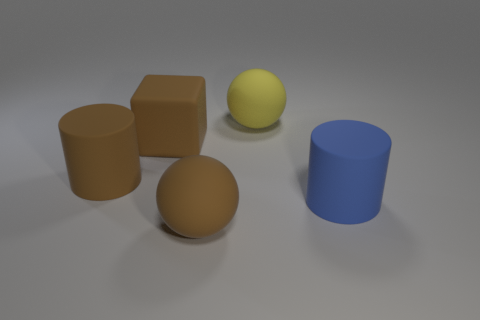What size is the rubber cylinder that is the same color as the cube?
Give a very brief answer. Large. Are there any other objects that have the same shape as the large blue matte object?
Make the answer very short. Yes. There is a brown matte object that is on the left side of the big brown rubber block; is it the same shape as the big matte object that is in front of the large blue thing?
Provide a succinct answer. No. There is a rubber object that is to the right of the large brown sphere and in front of the large block; what shape is it?
Make the answer very short. Cylinder. Is there a gray object that has the same size as the yellow rubber ball?
Your answer should be compact. No. Do the block and the rubber cylinder that is left of the big brown block have the same color?
Offer a terse response. Yes. What material is the large blue object?
Provide a short and direct response. Rubber. The rubber sphere in front of the blue cylinder is what color?
Give a very brief answer. Brown. What number of matte objects are the same color as the cube?
Provide a succinct answer. 2. What number of large objects are both in front of the rubber block and on the left side of the yellow rubber sphere?
Your answer should be very brief. 2. 